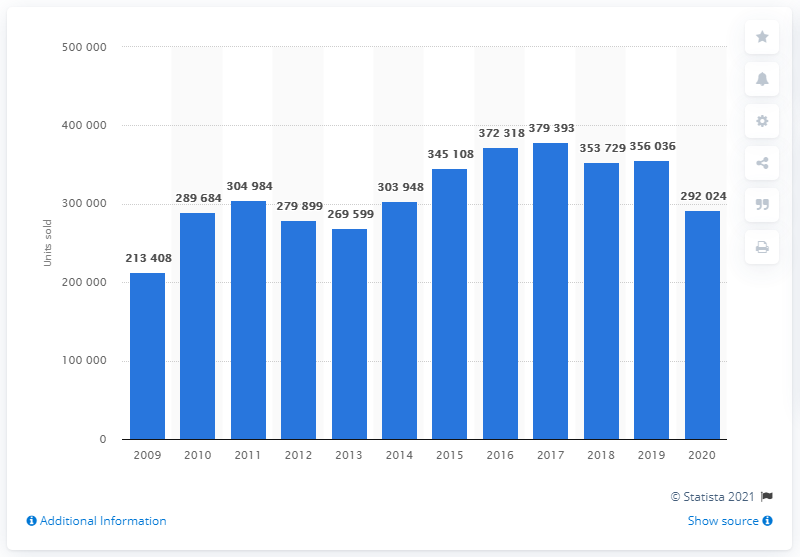Outline some significant characteristics in this image. In 2009, a total of 213,408 cars were sold in Sweden. It is estimated that 379,393 cars were sold in Sweden in 2017. In 2020, a total of 292,024 passenger cars were sold in Sweden. 